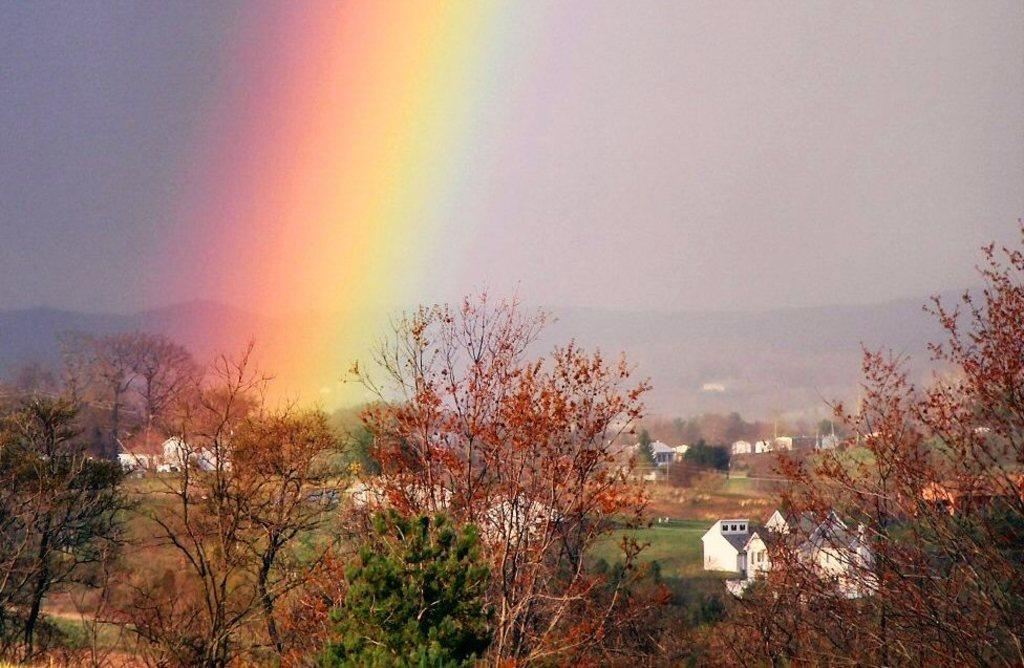What type of vegetation is present at the bottom of the image? There are trees and grass at the bottom of the image. What structures can be seen at the bottom of the image? There are buildings at the bottom of the image. What is visible in the sky in the image? The sky is visible at the top of the image, and there is a rainbow in the sky. What type of landscape feature is visible in the background of the image? There are mountains in the background of the image. What type of furniture is visible in the garden in the image? There is no furniture or garden present in the image. How does the rainbow cover the entire sky in the image? The rainbow does not cover the entire sky in the image; it is only a portion of the sky. 